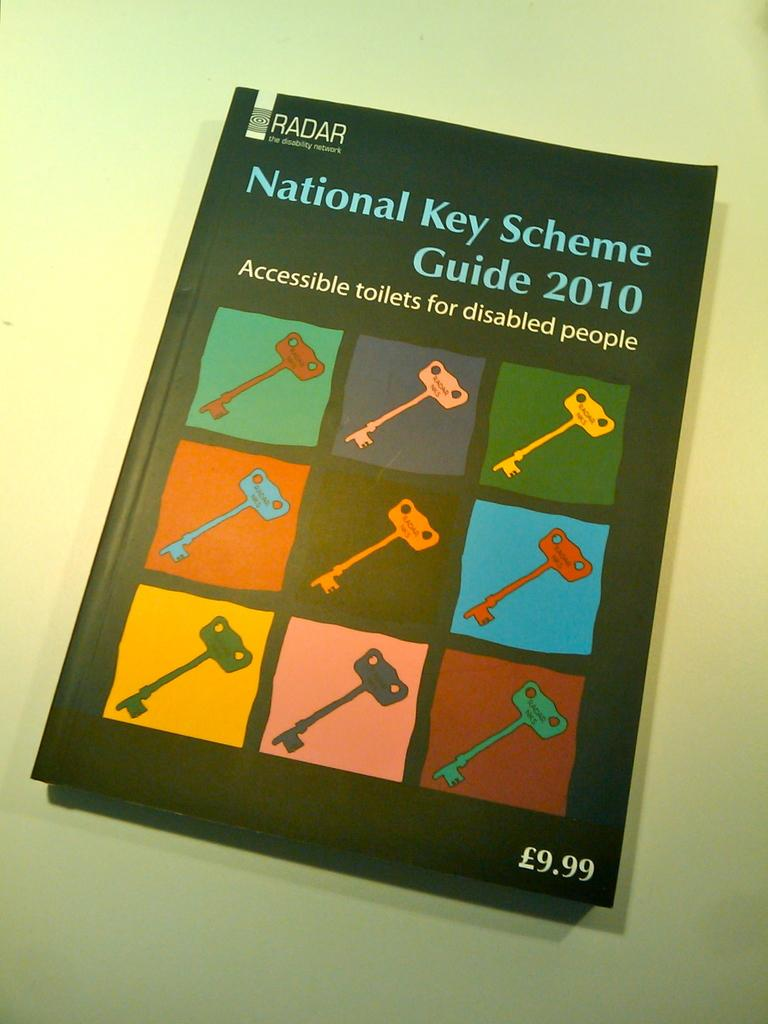Provide a one-sentence caption for the provided image. a book entitled National Key Scheme Guide 2010 for disabled people. 